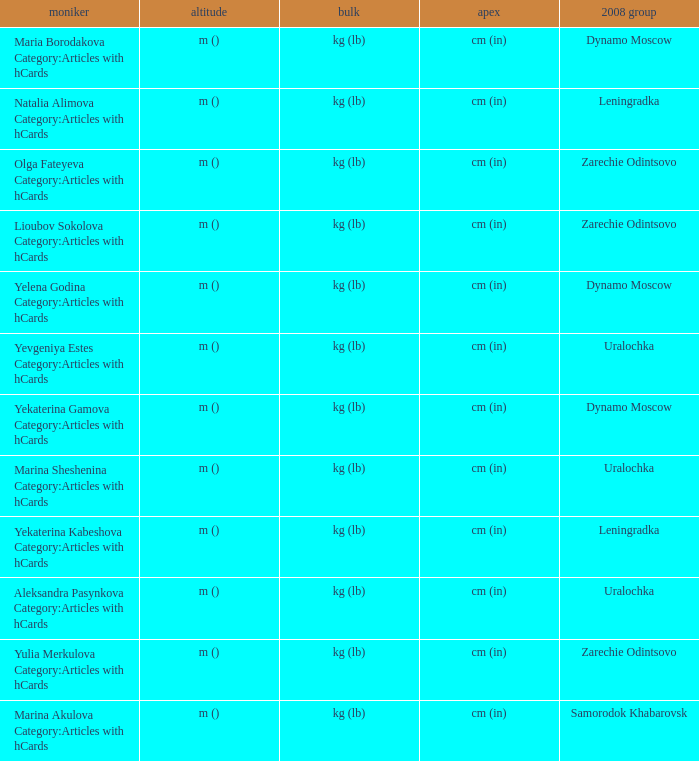What is the name when the 2008 club is uralochka? Yevgeniya Estes Category:Articles with hCards, Marina Sheshenina Category:Articles with hCards, Aleksandra Pasynkova Category:Articles with hCards. 